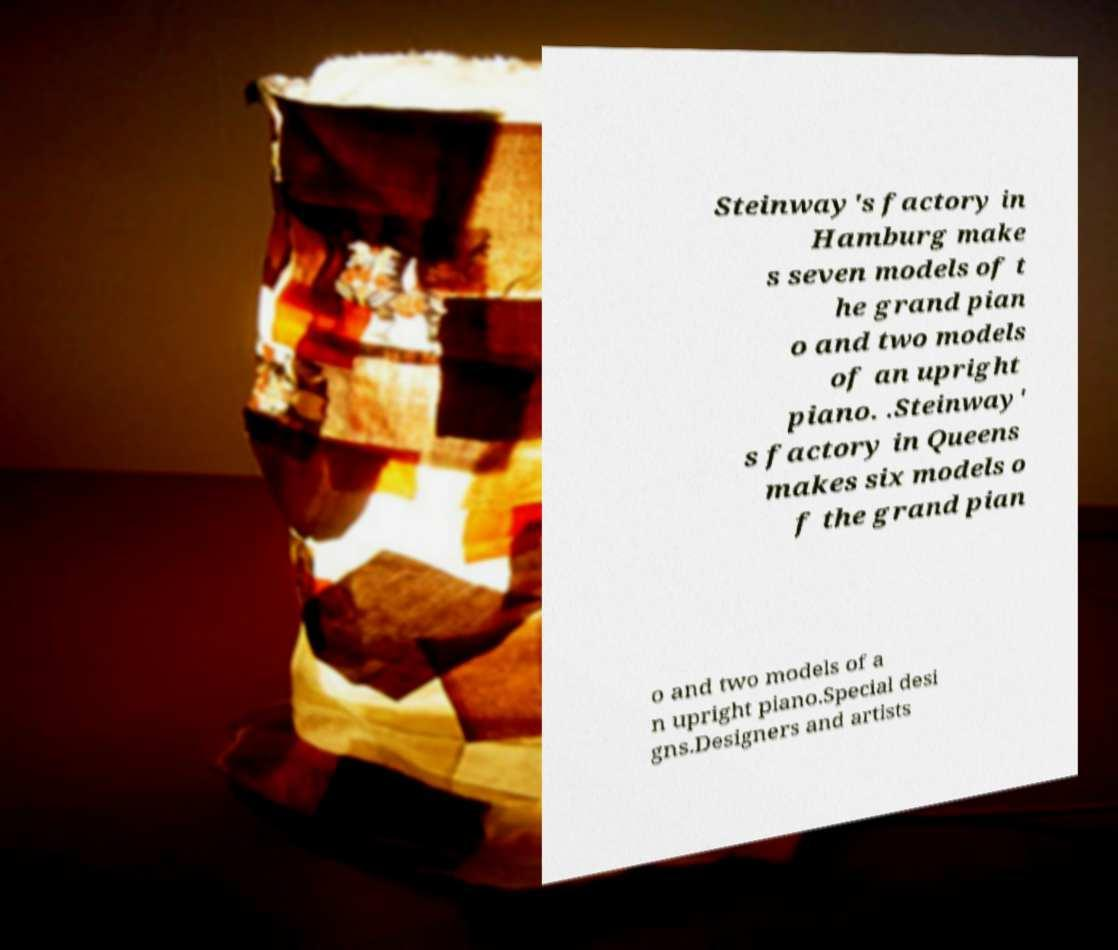Please read and relay the text visible in this image. What does it say? Steinway's factory in Hamburg make s seven models of t he grand pian o and two models of an upright piano. .Steinway' s factory in Queens makes six models o f the grand pian o and two models of a n upright piano.Special desi gns.Designers and artists 